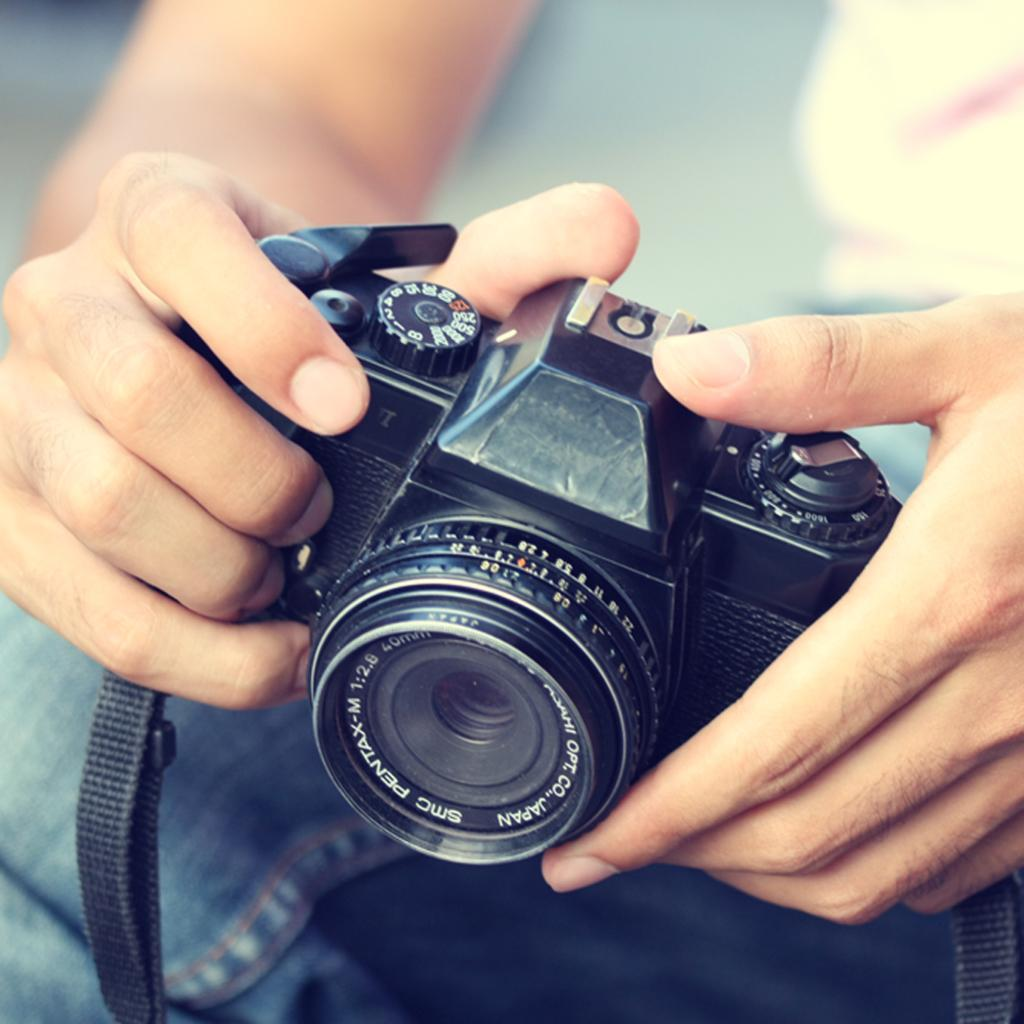What is the main subject of the image? There is a person in the image. What is the person holding in the image? The person is holding a camera. How many bears are visible in the image? There are no bears present in the image. 